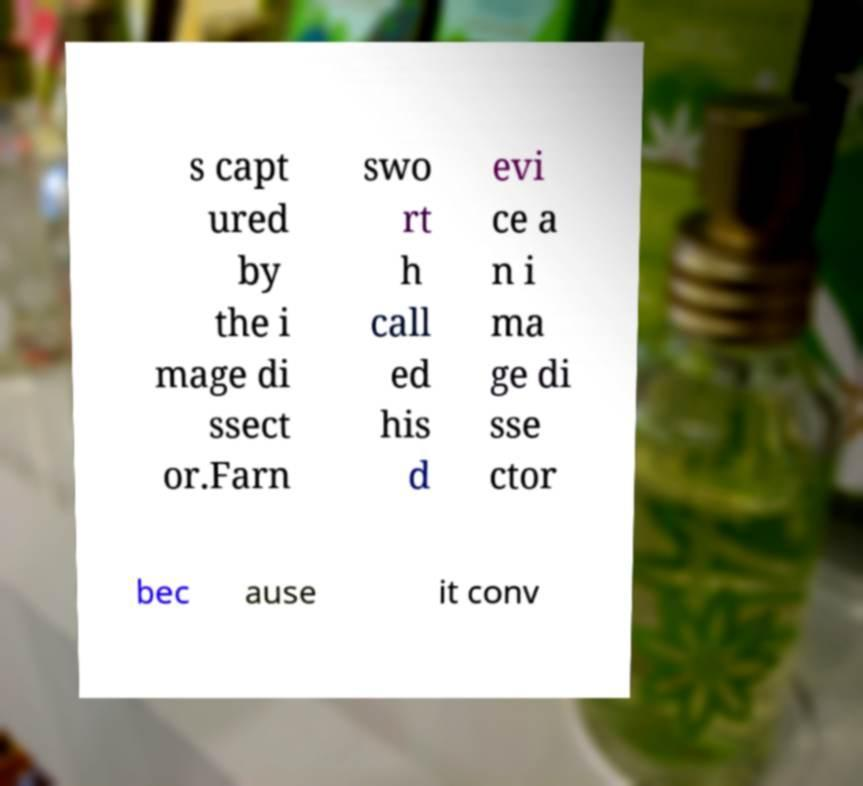I need the written content from this picture converted into text. Can you do that? s capt ured by the i mage di ssect or.Farn swo rt h call ed his d evi ce a n i ma ge di sse ctor bec ause it conv 